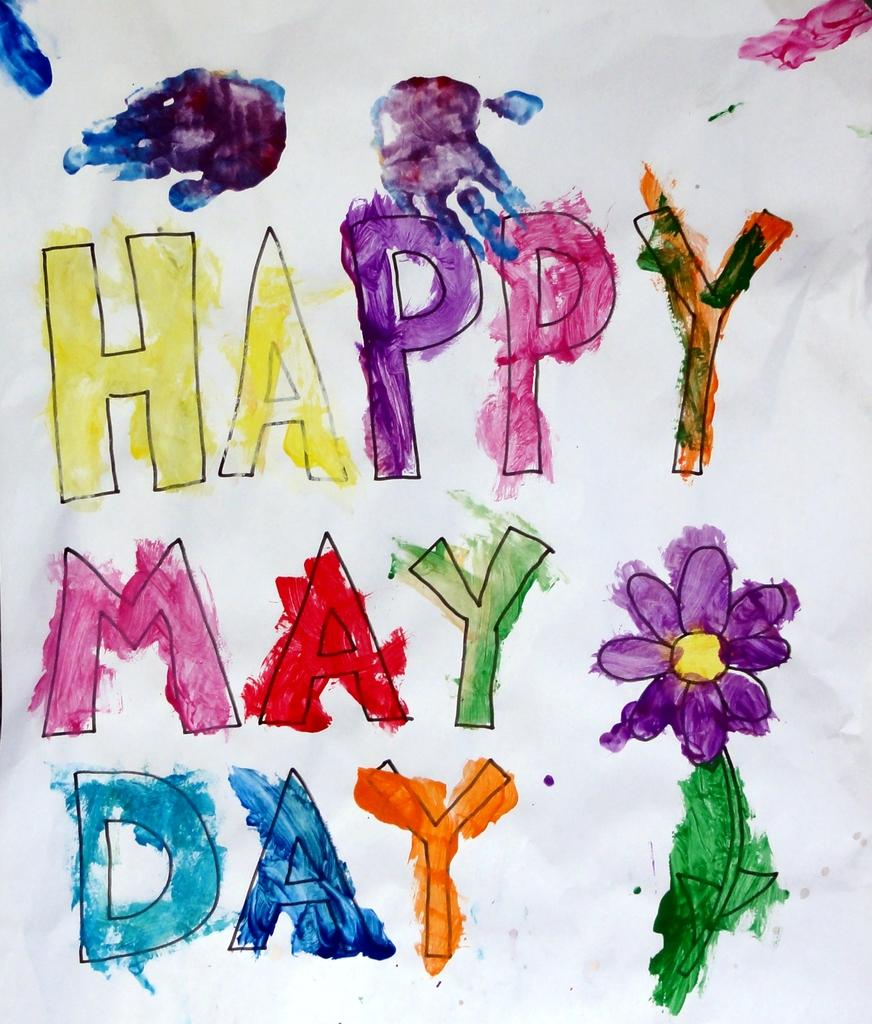What is depicted in the image? There is a text and a flower in the image. How are the text and the flower represented in the image? The text and the flower are painted with watercolors. Can you describe the style of the painting? The text and the flower are painted with watercolors, which gives them a soft and fluid appearance. How much sugar is used to paint the flower in the image? There is no sugar used to paint the flower in the image; it is painted with watercolors}. Is there a rail visible in the image? There is no rail present in the image. 